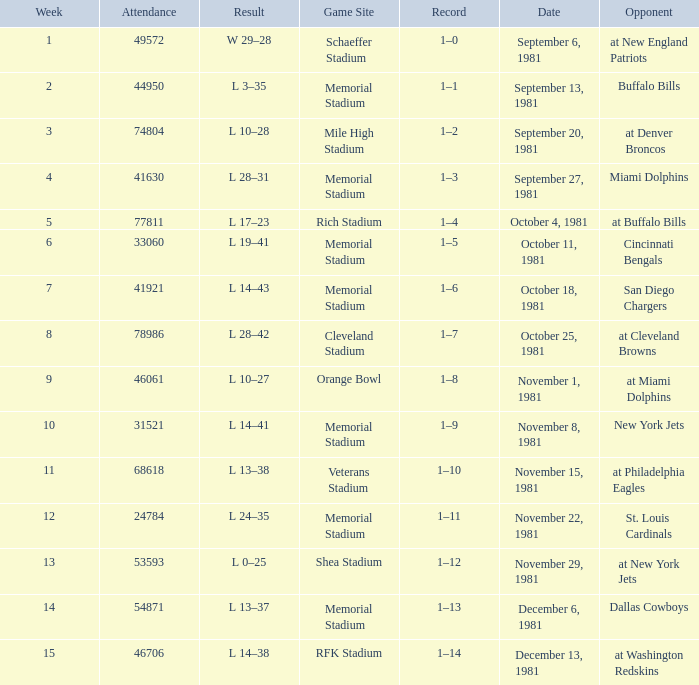When it is week 2 what is the record? 1–1. 